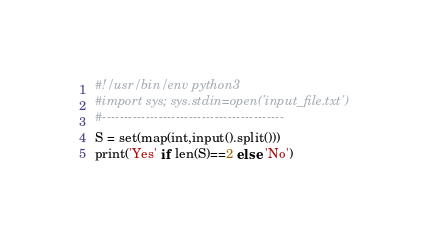<code> <loc_0><loc_0><loc_500><loc_500><_Python_>#!/usr/bin/env python3
#import sys; sys.stdin=open('input_file.txt')
#------------------------------------------
S = set(map(int,input().split()))
print('Yes' if len(S)==2 else 'No')
</code> 